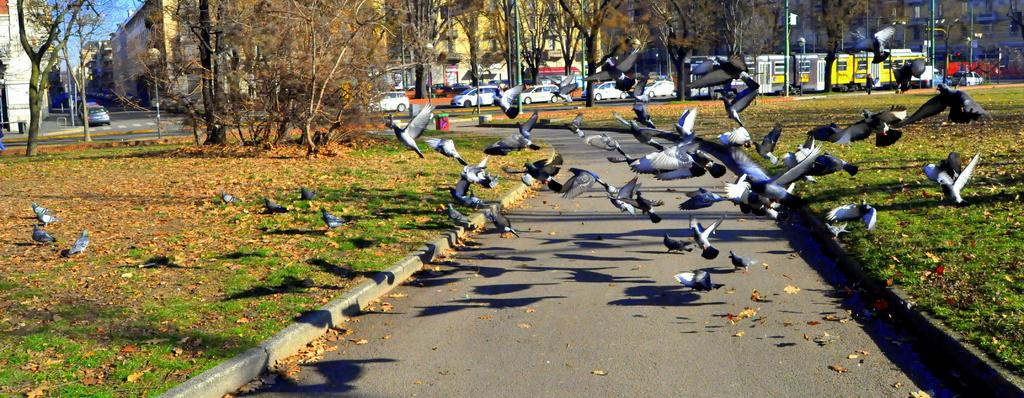What type of animals can be seen in the image? Birds can be seen in the image. Who else is present in the image besides the birds? There are people in the image. What can be seen in the distance in the background of the image? There are vehicles, a train, poles, trees, and buildings in the background of the image. What type of kite is being flown by the statement in the image? There is no kite or statement present in the image. How does the person holding the kite shake the train in the image? There is no person holding a kite or train present in the image. 